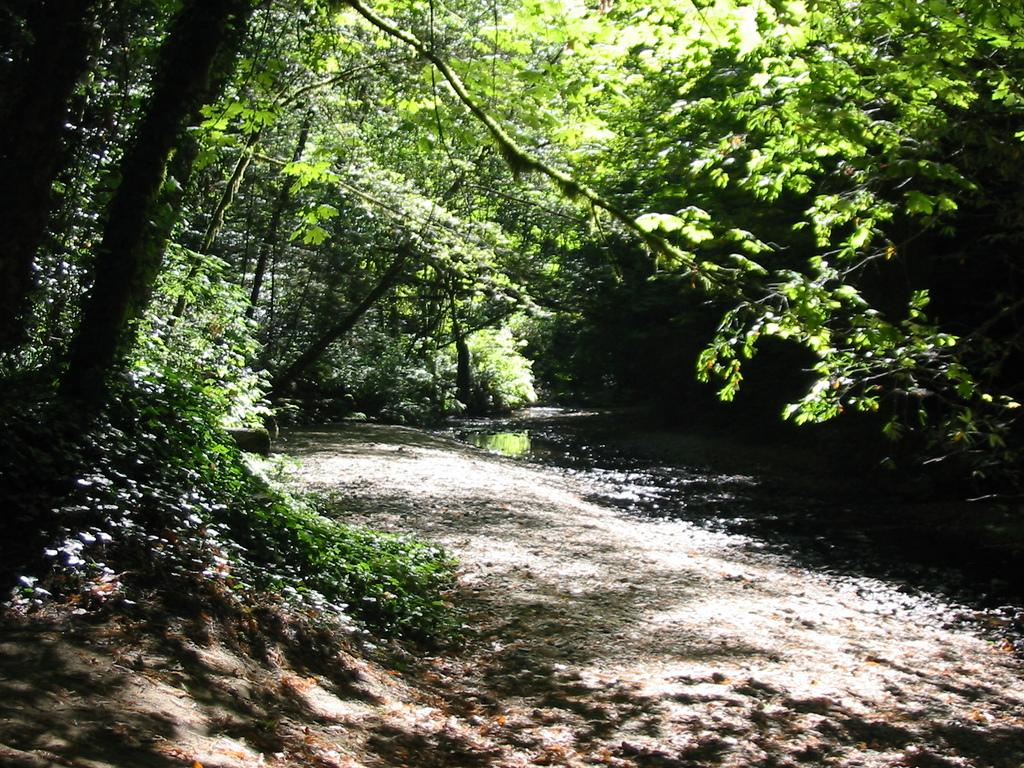What type of vegetation can be seen in the image? There are trees and plants in the image. What is the condition of the leaves on the trees and plants? Dry leaves are present in the image. Is there any water visible in the image? Yes, there is water visible in the image. Where is the cellar located in the image? There is no cellar present in the image. What type of friction can be observed between the plants in the image? There is no friction between the plants in the image, as they are not interacting with each other. 